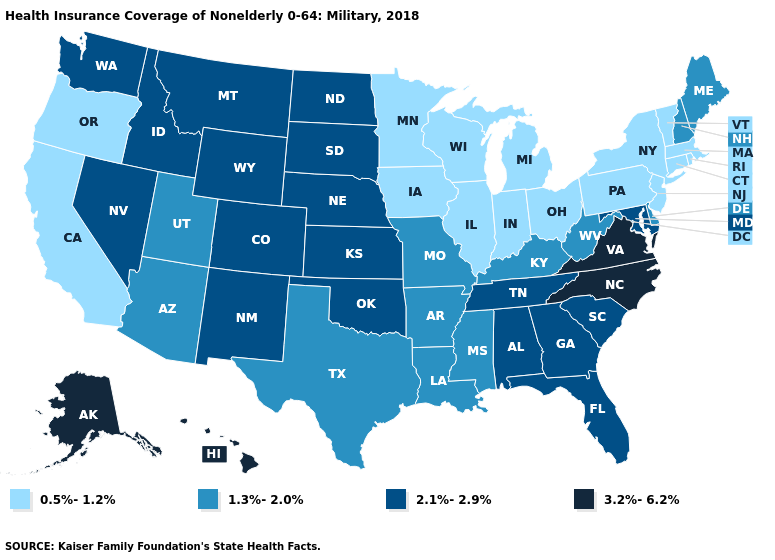What is the value of Delaware?
Concise answer only. 1.3%-2.0%. Is the legend a continuous bar?
Concise answer only. No. Name the states that have a value in the range 0.5%-1.2%?
Keep it brief. California, Connecticut, Illinois, Indiana, Iowa, Massachusetts, Michigan, Minnesota, New Jersey, New York, Ohio, Oregon, Pennsylvania, Rhode Island, Vermont, Wisconsin. What is the lowest value in the MidWest?
Answer briefly. 0.5%-1.2%. Among the states that border Oklahoma , which have the lowest value?
Keep it brief. Arkansas, Missouri, Texas. Does Utah have the lowest value in the West?
Give a very brief answer. No. What is the value of Oklahoma?
Be succinct. 2.1%-2.9%. Does Kentucky have a higher value than Wisconsin?
Concise answer only. Yes. What is the lowest value in the Northeast?
Give a very brief answer. 0.5%-1.2%. What is the value of Delaware?
Answer briefly. 1.3%-2.0%. Name the states that have a value in the range 0.5%-1.2%?
Write a very short answer. California, Connecticut, Illinois, Indiana, Iowa, Massachusetts, Michigan, Minnesota, New Jersey, New York, Ohio, Oregon, Pennsylvania, Rhode Island, Vermont, Wisconsin. Does Maine have the lowest value in the Northeast?
Short answer required. No. What is the value of Massachusetts?
Answer briefly. 0.5%-1.2%. Name the states that have a value in the range 2.1%-2.9%?
Write a very short answer. Alabama, Colorado, Florida, Georgia, Idaho, Kansas, Maryland, Montana, Nebraska, Nevada, New Mexico, North Dakota, Oklahoma, South Carolina, South Dakota, Tennessee, Washington, Wyoming. Does the first symbol in the legend represent the smallest category?
Answer briefly. Yes. 